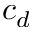Convert formula to latex. <formula><loc_0><loc_0><loc_500><loc_500>c _ { d }</formula> 